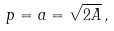<formula> <loc_0><loc_0><loc_500><loc_500>p = a = { \sqrt { 2 A } } \, ,</formula> 